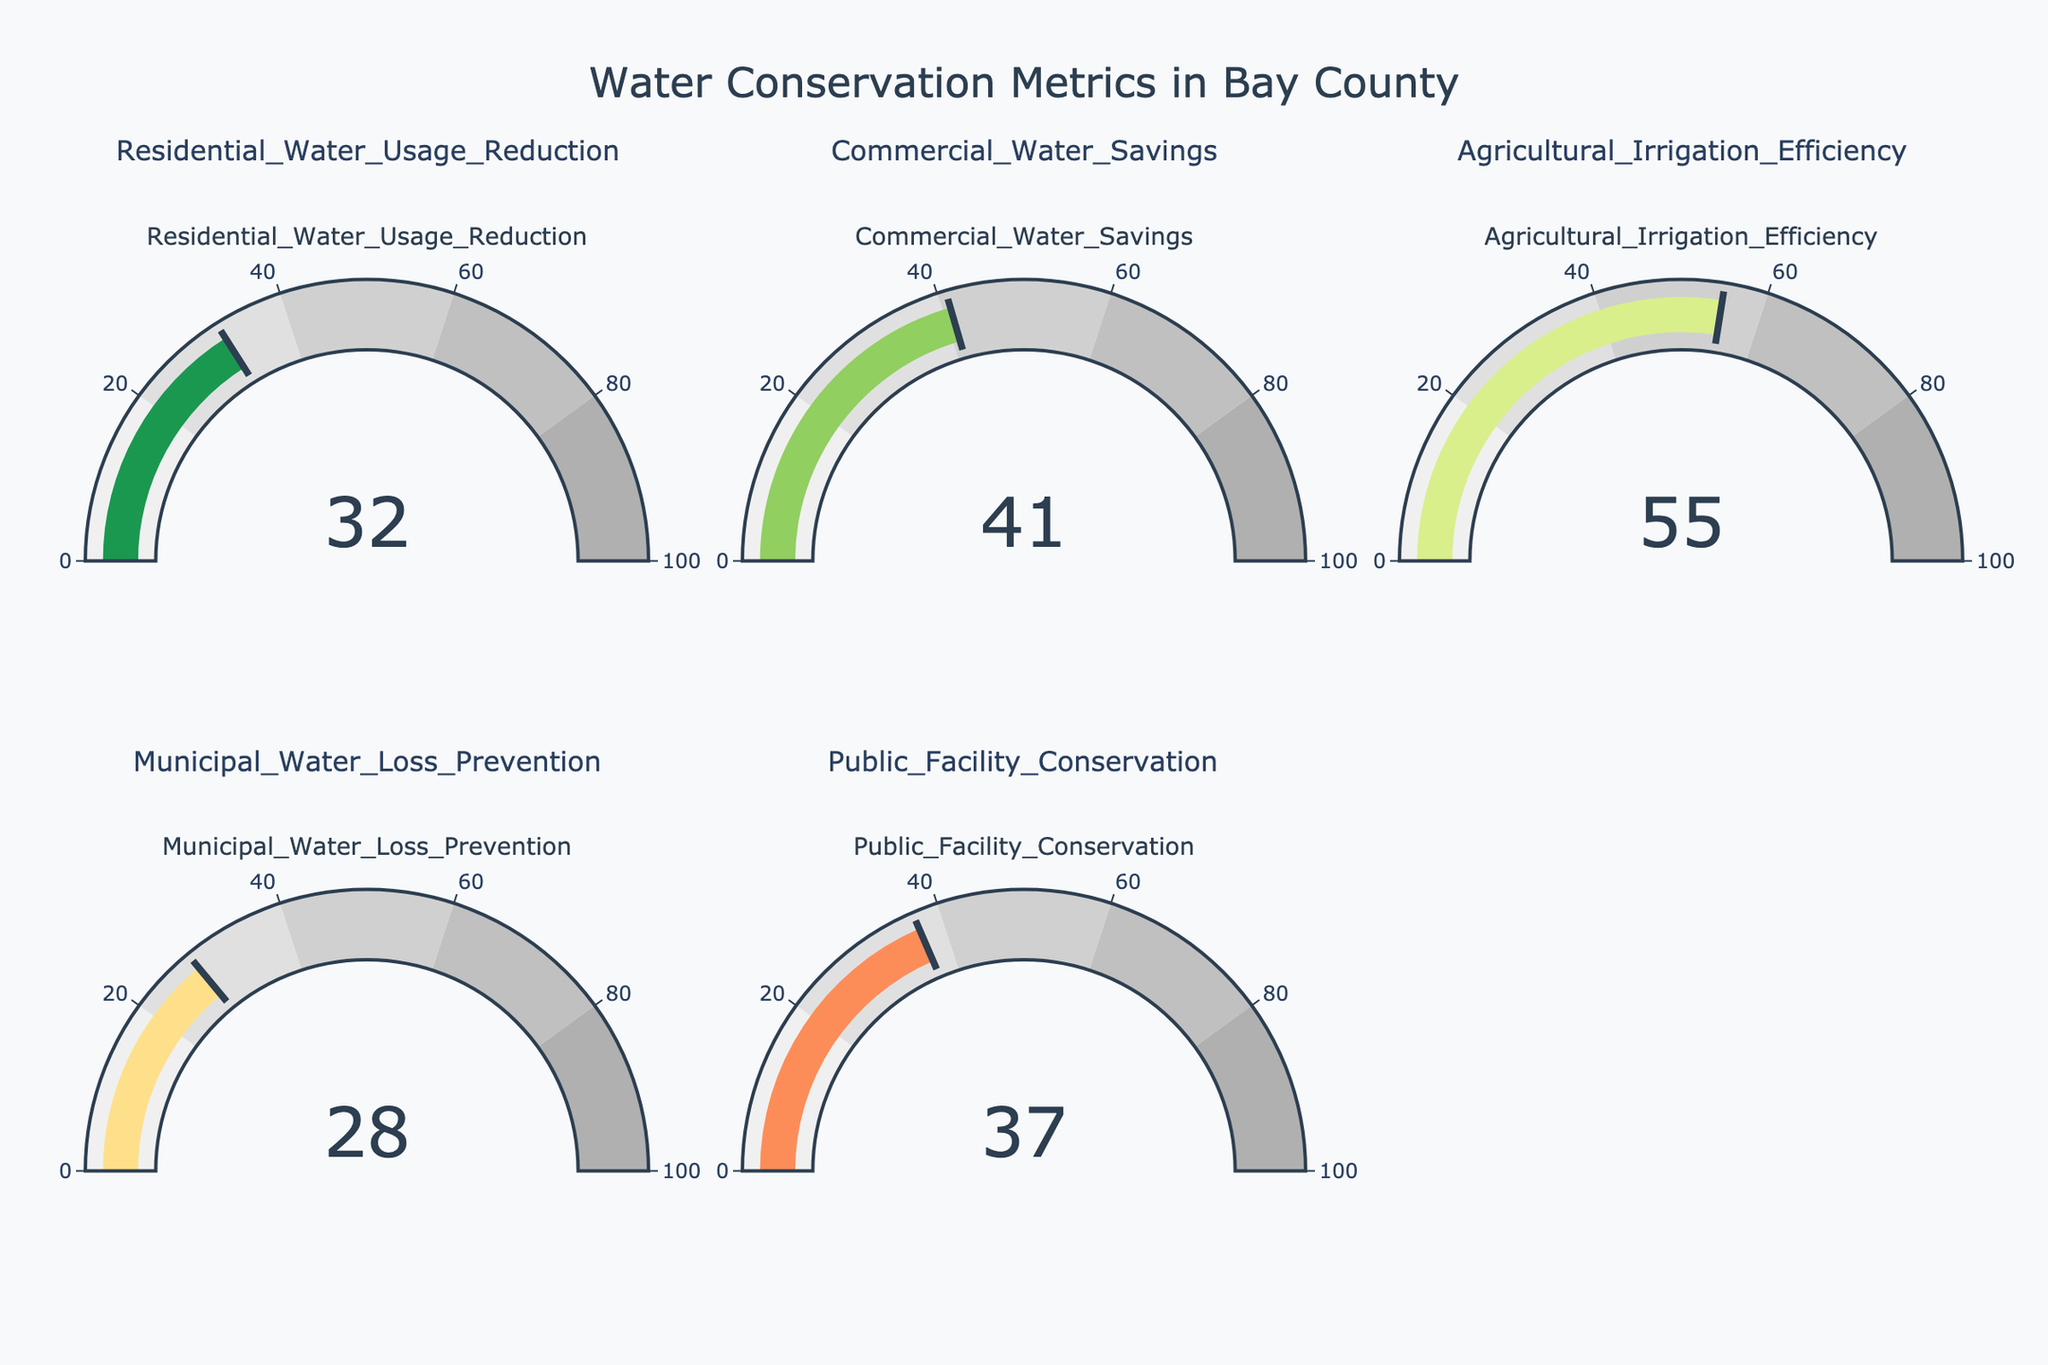Which water conservation metric has the highest value? Look at the values displayed on each gauge chart. Agricultural Irrigation Efficiency has the highest value at 55.
Answer: Agricultural Irrigation Efficiency Which water conservation metric has the lowest value? Examine the values on each gauge chart. Municipal Water Loss Prevention has the lowest value at 28.
Answer: Municipal Water Loss Prevention What is the difference between the highest and lowest water conservation metrics? The highest metric is 55 (Agricultural Irrigation Efficiency) and the lowest is 28 (Municipal Water Loss Prevention). The difference is 55 - 28 = 27.
Answer: 27 What are the average values of the water conservation metrics? Sum all the values (32 + 41 + 55 + 28 + 37) = 193 and divide by the number of metrics (5). The average is 193 / 5 = 38.6.
Answer: 38.6 Which metric shows a value closest to the overall average value? The overall average value is 38.6. The closest values are Residential Water Usage Reduction (32), Commercial Water Savings (41), Agricultural Irrigation Efficiency (55), Municipal Water Loss Prevention (28), and Public Facility Conservation (37). The closest is Commercial Water Savings at 41.
Answer: Commercial Water Savings How many water conservation metrics have a value above 30? Count the number of metrics with values above 30. Residential Water Usage Reduction (32), Commercial Water Savings (41), Agricultural Irrigation Efficiency (55), and Public Facility Conservation (37). Total count is 4.
Answer: 4 How many water conservation metrics are below the average value? The average value is 38.6. Metrics below the average value: Residential Water Usage Reduction (32), Municipal Water Loss Prevention (28), Public Facility Conservation (37). Total count is 3.
Answer: 3 Considering the color scale, which metric is in the green zone reflecting strong performance? The green zone corresponds to higher values. Agricultural Irrigation Efficiency, with a value of 55, lies in this zone.
Answer: Agricultural Irrigation Efficiency 